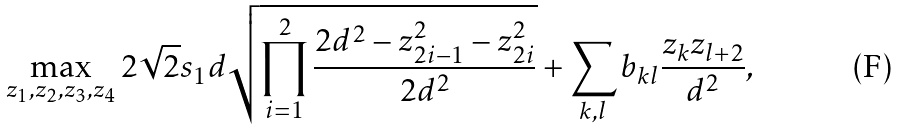<formula> <loc_0><loc_0><loc_500><loc_500>\max _ { z _ { 1 } , z _ { 2 } , z _ { 3 } , z _ { 4 } } 2 \sqrt { 2 } s _ { 1 } d \sqrt { \prod _ { i = 1 } ^ { 2 } \frac { 2 d ^ { 2 } - z _ { 2 i - 1 } ^ { 2 } - z _ { 2 i } ^ { 2 } } { 2 d ^ { 2 } } } + \sum _ { k , l } b _ { k l } \frac { z _ { k } z _ { l + 2 } } { d ^ { 2 } } ,</formula> 